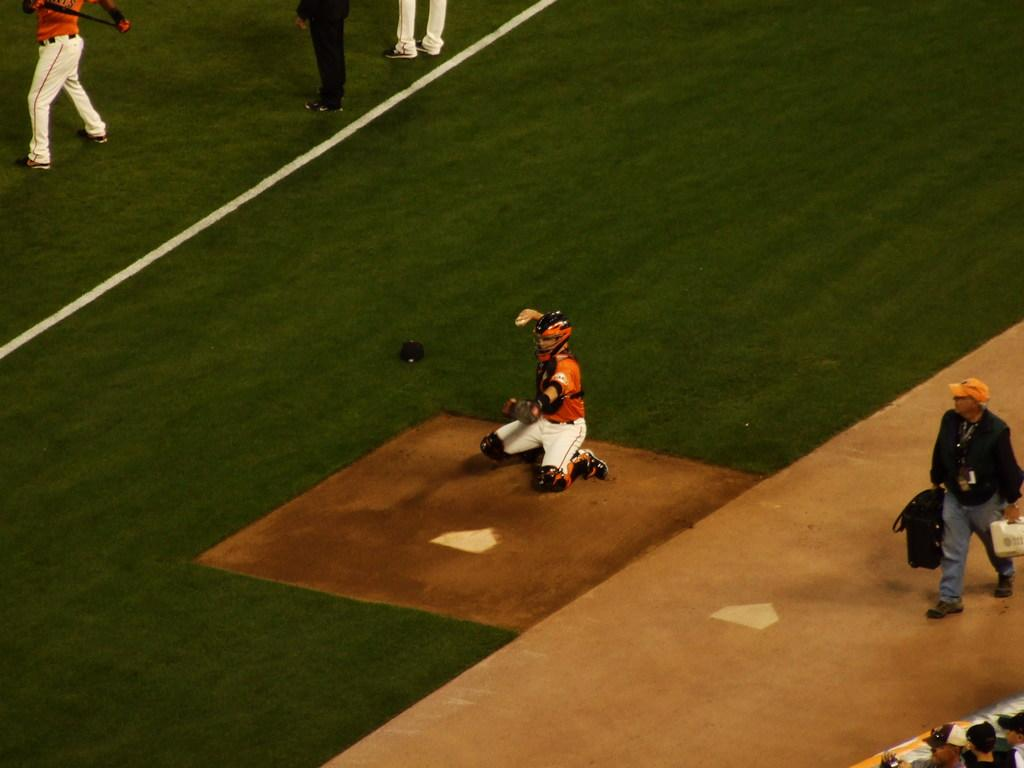What is the person in the image wearing on their head? The person in the image is wearing a helmet. What position is the person in? The person is sitting on the ground. Are there any other people visible in the image? Yes, there are other people visible in the image. What type of punishment is the person receiving in the image? There is no indication of punishment in the image; the person is simply sitting on the ground wearing a helmet. What kind of prose can be seen in the image? There is no prose visible in the image. 